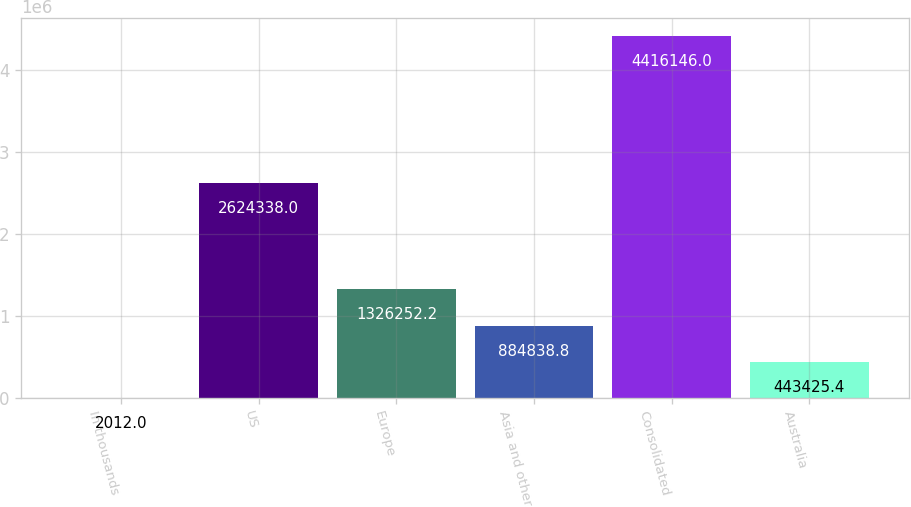Convert chart to OTSL. <chart><loc_0><loc_0><loc_500><loc_500><bar_chart><fcel>In thousands<fcel>US<fcel>Europe<fcel>Asia and other<fcel>Consolidated<fcel>Australia<nl><fcel>2012<fcel>2.62434e+06<fcel>1.32625e+06<fcel>884839<fcel>4.41615e+06<fcel>443425<nl></chart> 